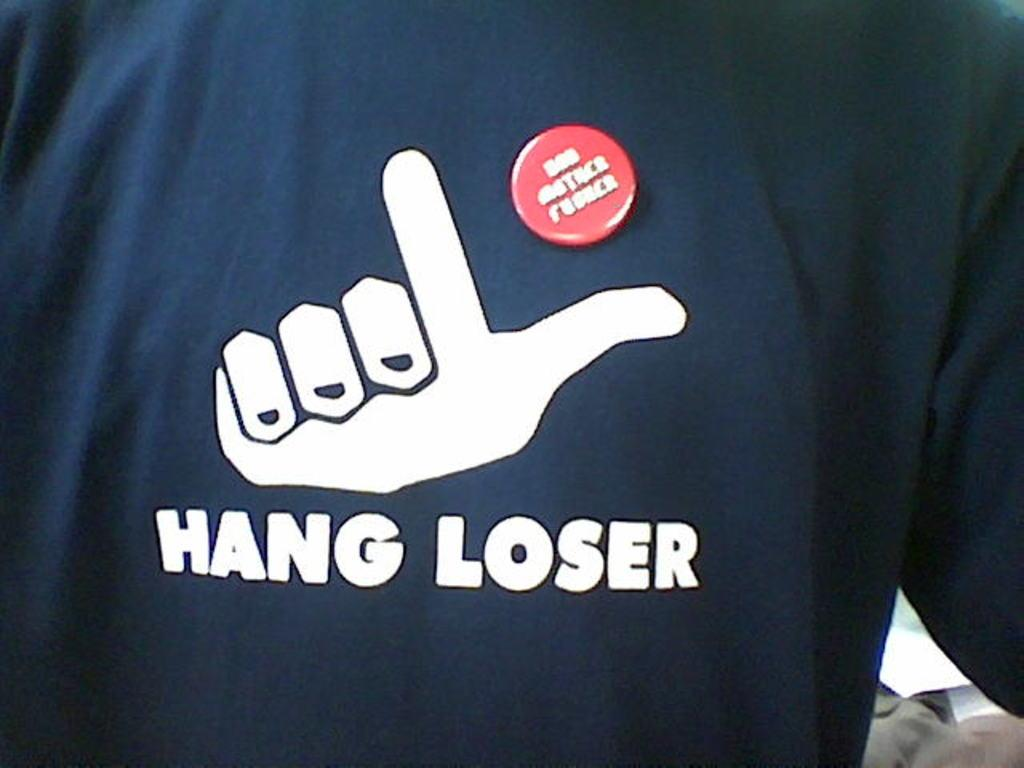<image>
Provide a brief description of the given image. the words hang loser are on the black shirt 